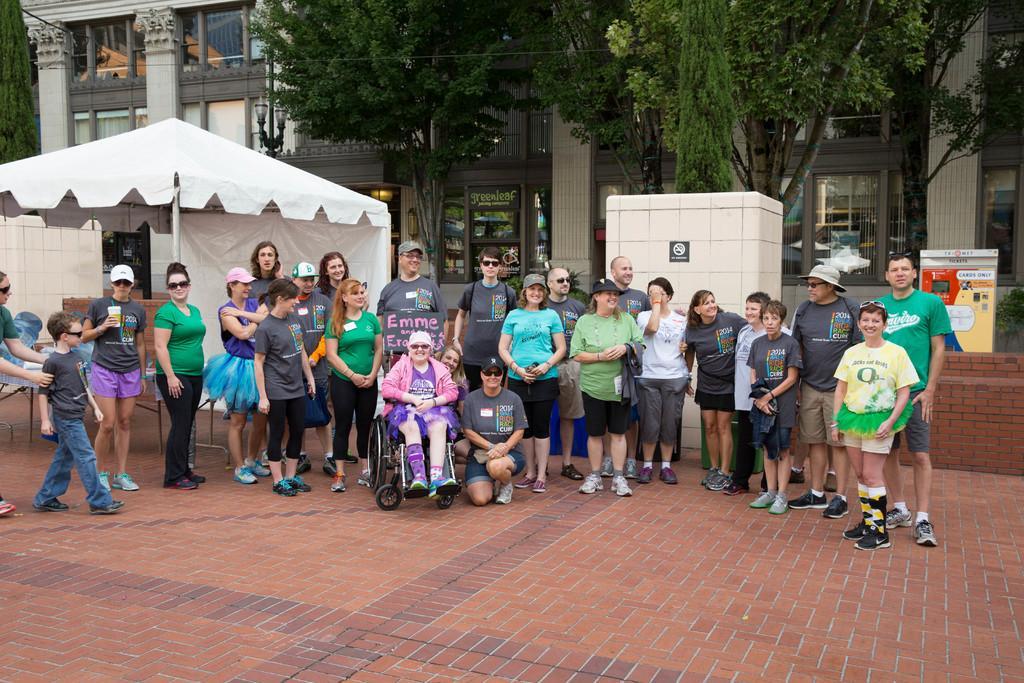Describe this image in one or two sentences. In the image i can see some group of persons standing, in the foreground of the image we can see two persons woman sitting on wheel chair, man crouching down and in the background of the image there are some trees, houses. 